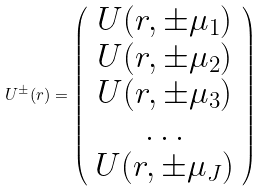<formula> <loc_0><loc_0><loc_500><loc_500>U ^ { \pm } ( r ) = \left ( \begin{array} { c } U ( r , \pm \mu _ { 1 } ) \\ U ( r , \pm \mu _ { 2 } ) \\ U ( r , \pm \mu _ { 3 } ) \\ \dots \\ U ( r , \pm \mu _ { J } ) \end{array} \right )</formula> 